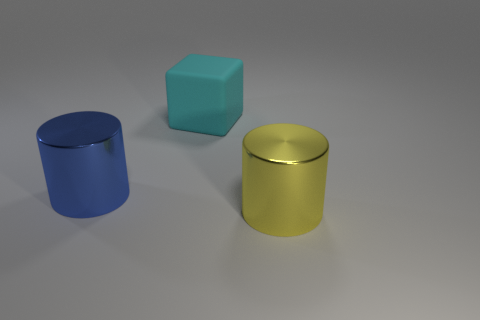Do the object to the left of the cyan cube and the large shiny thing to the right of the block have the same shape?
Your answer should be compact. Yes. Is there a cube that has the same size as the blue metallic cylinder?
Offer a very short reply. Yes. What is the material of the object to the right of the cyan object?
Provide a short and direct response. Metal. Do the thing in front of the large blue cylinder and the big cyan thing have the same material?
Give a very brief answer. No. Are any big cyan blocks visible?
Make the answer very short. Yes. What color is the big cylinder that is made of the same material as the large blue object?
Your answer should be compact. Yellow. There is a large thing that is behind the cylinder that is behind the big cylinder that is to the right of the rubber object; what color is it?
Offer a terse response. Cyan. There is a matte block; is its size the same as the shiny cylinder to the left of the yellow cylinder?
Provide a short and direct response. Yes. What number of things are either big metallic cylinders that are in front of the big blue cylinder or large things in front of the blue shiny cylinder?
Ensure brevity in your answer.  1. What shape is the cyan rubber object that is the same size as the yellow metallic object?
Your answer should be compact. Cube. 